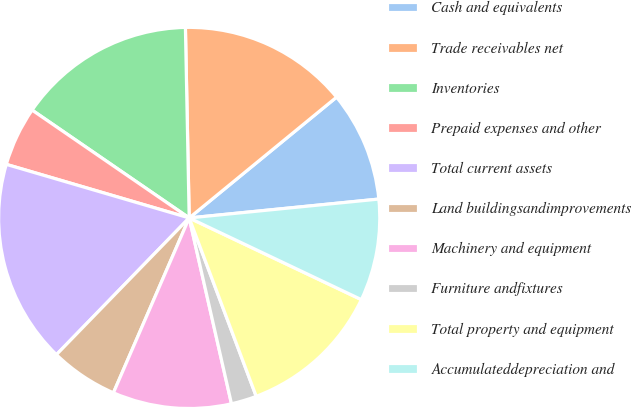Convert chart to OTSL. <chart><loc_0><loc_0><loc_500><loc_500><pie_chart><fcel>Cash and equivalents<fcel>Trade receivables net<fcel>Inventories<fcel>Prepaid expenses and other<fcel>Total current assets<fcel>Land buildingsandimprovements<fcel>Machinery and equipment<fcel>Furniture andfixtures<fcel>Total property and equipment<fcel>Accumulateddepreciation and<nl><fcel>9.35%<fcel>14.39%<fcel>15.11%<fcel>5.04%<fcel>17.27%<fcel>5.76%<fcel>10.07%<fcel>2.16%<fcel>12.23%<fcel>8.63%<nl></chart> 